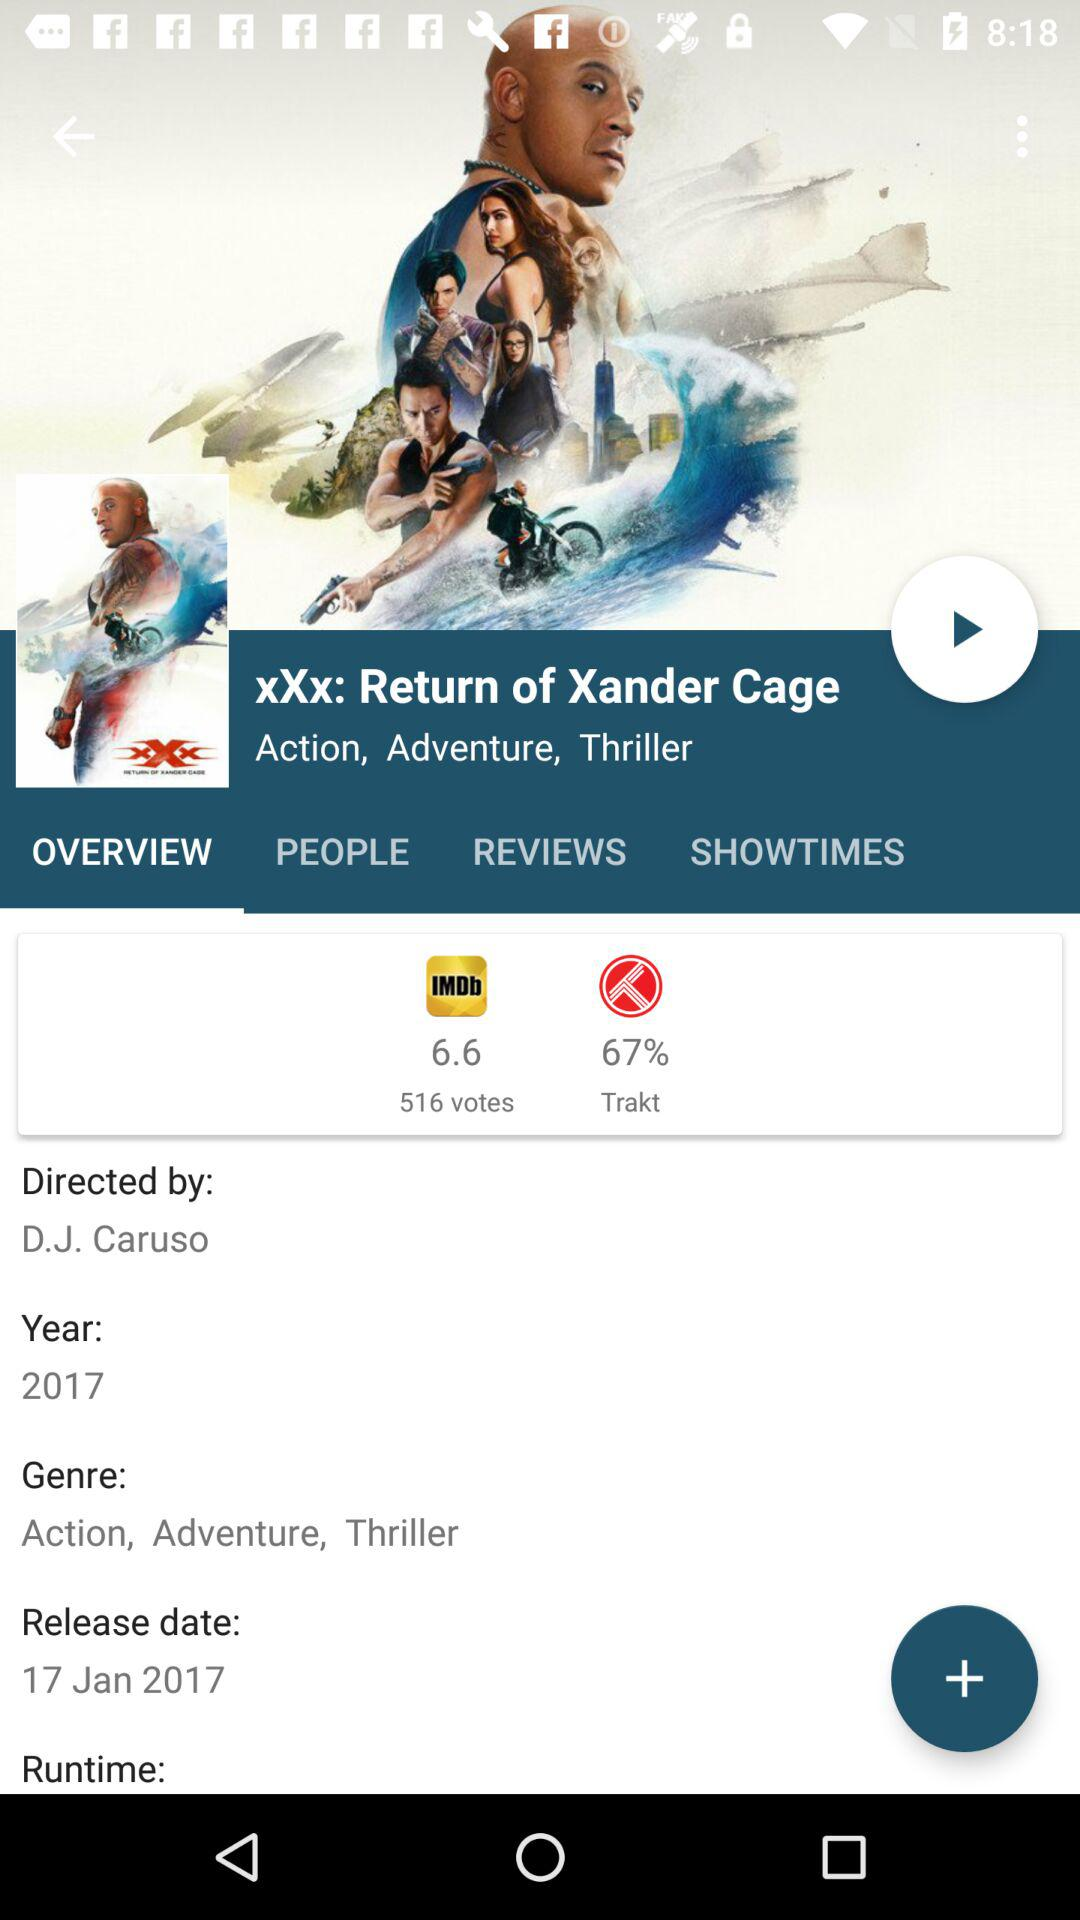In what year was the movie released? The movie was released in 2017. 